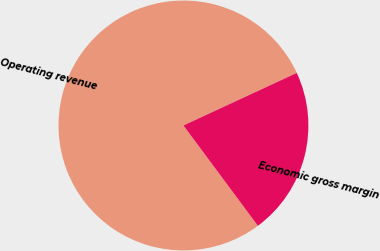Convert chart. <chart><loc_0><loc_0><loc_500><loc_500><pie_chart><fcel>Operating revenue<fcel>Economic gross margin<nl><fcel>78.25%<fcel>21.75%<nl></chart> 